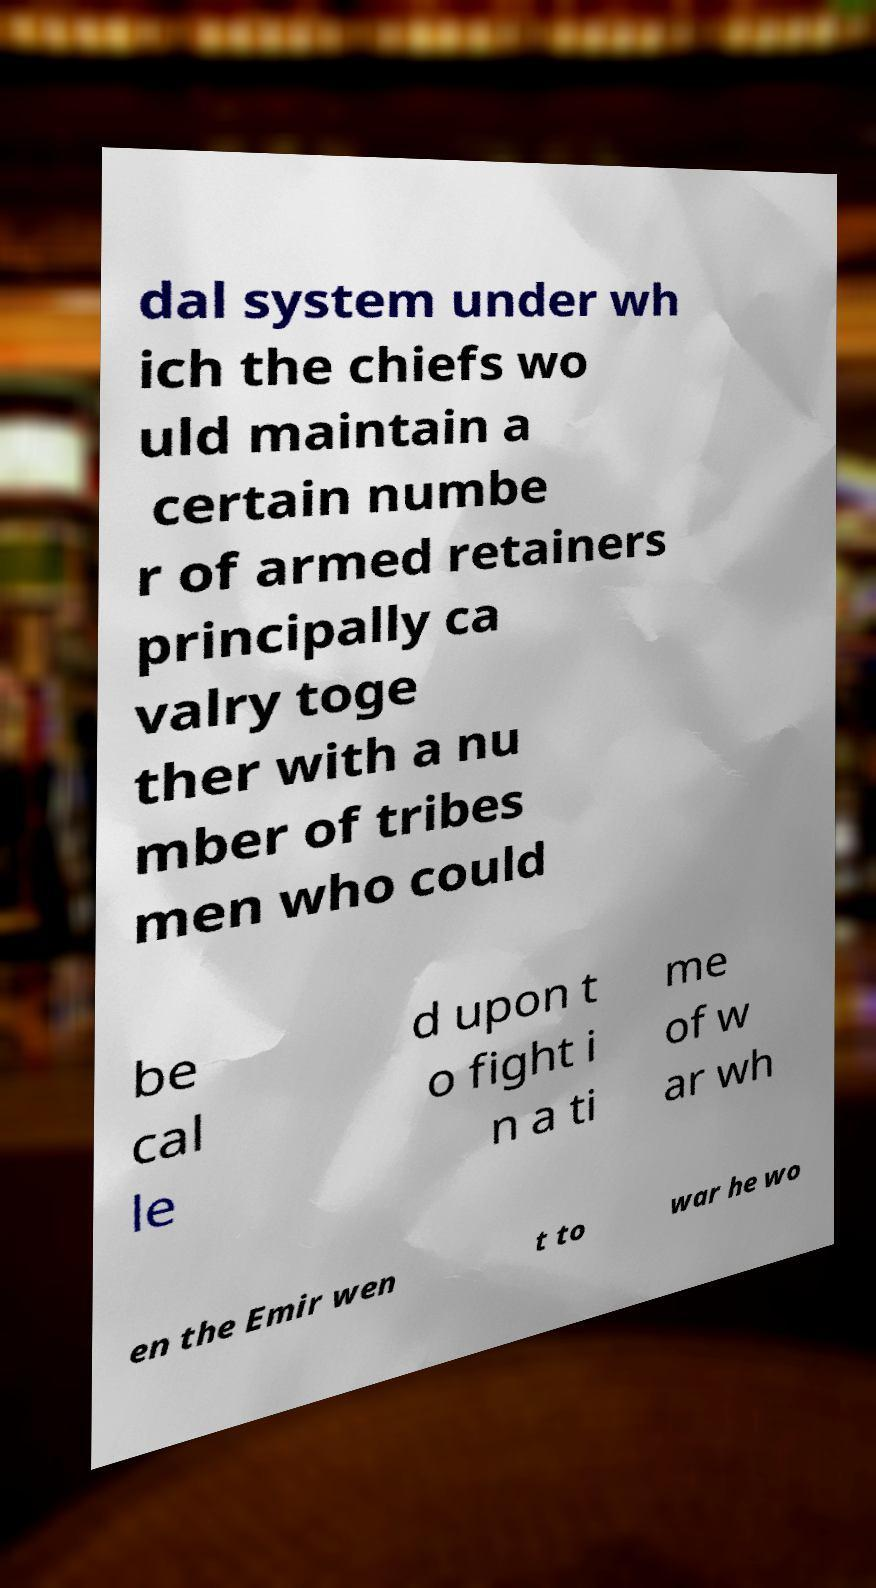Please identify and transcribe the text found in this image. dal system under wh ich the chiefs wo uld maintain a certain numbe r of armed retainers principally ca valry toge ther with a nu mber of tribes men who could be cal le d upon t o fight i n a ti me of w ar wh en the Emir wen t to war he wo 